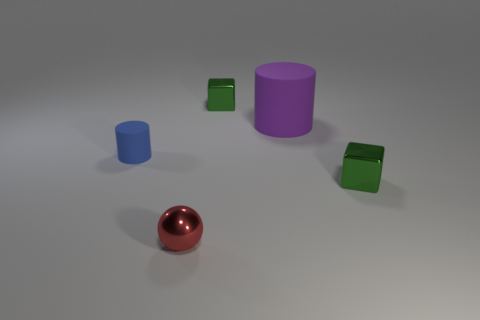What number of blue matte cylinders are behind the tiny matte cylinder that is behind the small ball that is in front of the big matte cylinder?
Make the answer very short. 0. Is the red ball in front of the purple cylinder made of the same material as the tiny green thing in front of the big rubber cylinder?
Make the answer very short. Yes. What number of big purple objects are the same shape as the blue thing?
Your response must be concise. 1. Are there more big purple things that are to the left of the small red metallic object than blue cylinders?
Give a very brief answer. No. What is the shape of the small green metallic thing in front of the small matte thing to the left of the cylinder that is behind the small blue rubber object?
Keep it short and to the point. Cube. Do the matte object that is right of the tiny rubber object and the green shiny thing that is in front of the blue object have the same shape?
Keep it short and to the point. No. Is there anything else that has the same size as the purple rubber thing?
Offer a very short reply. No. What number of cylinders are either blue objects or tiny green things?
Make the answer very short. 1. Are the purple cylinder and the blue thing made of the same material?
Offer a terse response. Yes. How many other things are there of the same color as the small rubber cylinder?
Your response must be concise. 0. 